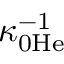<formula> <loc_0><loc_0><loc_500><loc_500>\kappa _ { 0 H e } ^ { - 1 }</formula> 